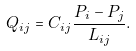<formula> <loc_0><loc_0><loc_500><loc_500>Q _ { i j } = C _ { i j } \frac { P _ { i } - P _ { j } } { L _ { i j } } .</formula> 